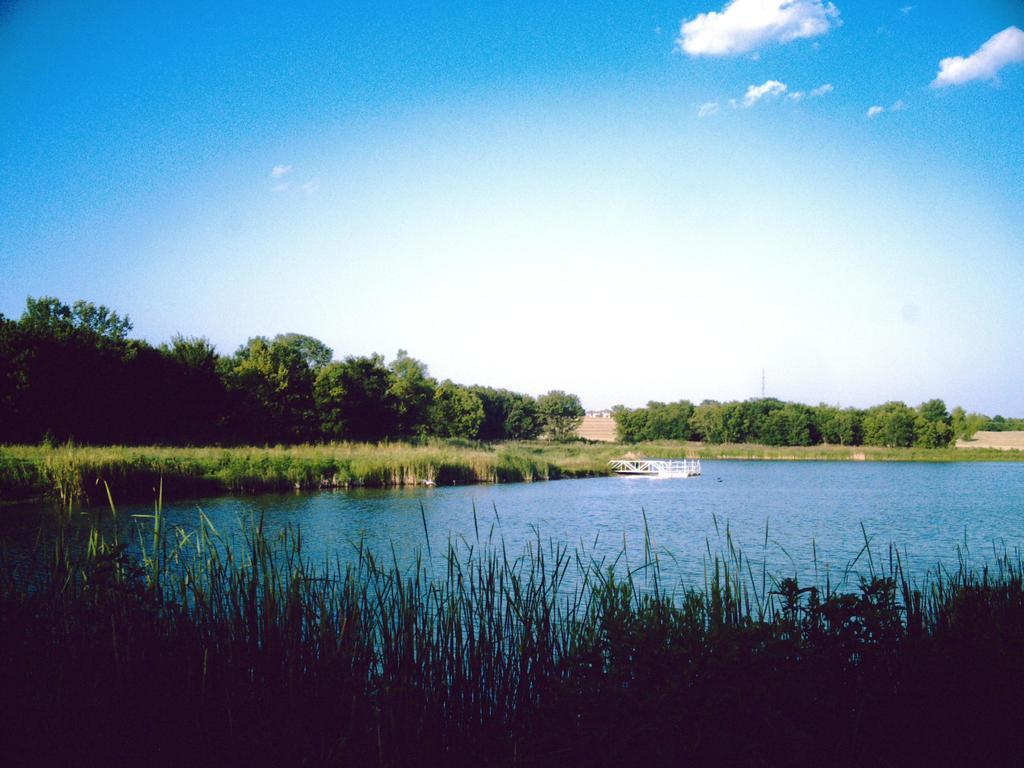What type of vegetation is present in the image? There are trees in the image. What is the ground covered with in the image? There is grass in the image. What natural element is also present in the image? There is water in the image. What is visible at the top of the image? The sky is visible in the image. What can be seen in the sky in the image? There are clouds in the image. Can you see a seashore in the image? There is no seashore present in the image. What type of patch is visible on the trees in the image? There are no patches visible on the trees in the image. 